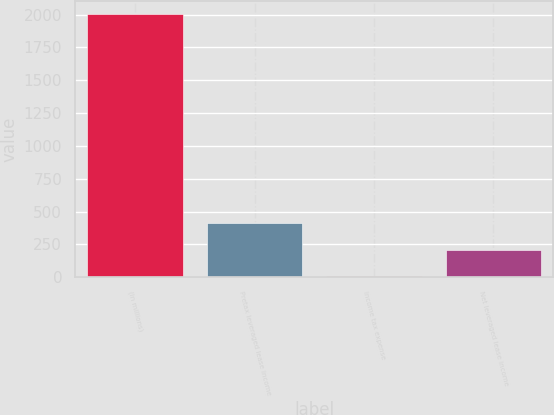Convert chart to OTSL. <chart><loc_0><loc_0><loc_500><loc_500><bar_chart><fcel>(in millions)<fcel>Pretax leveraged lease income<fcel>Income tax expense<fcel>Net leveraged lease income<nl><fcel>2005<fcel>409.8<fcel>11<fcel>210.4<nl></chart> 